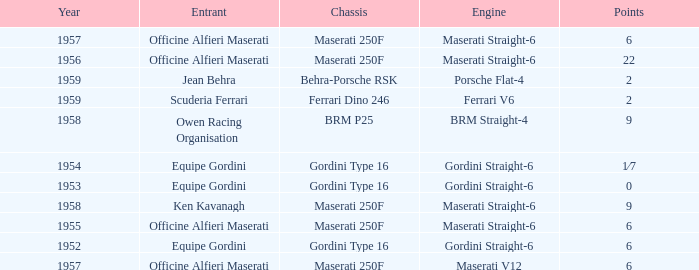What is the entrant of a chassis maserati 250f, also has 6 points and older than year 1957? Officine Alfieri Maserati. 